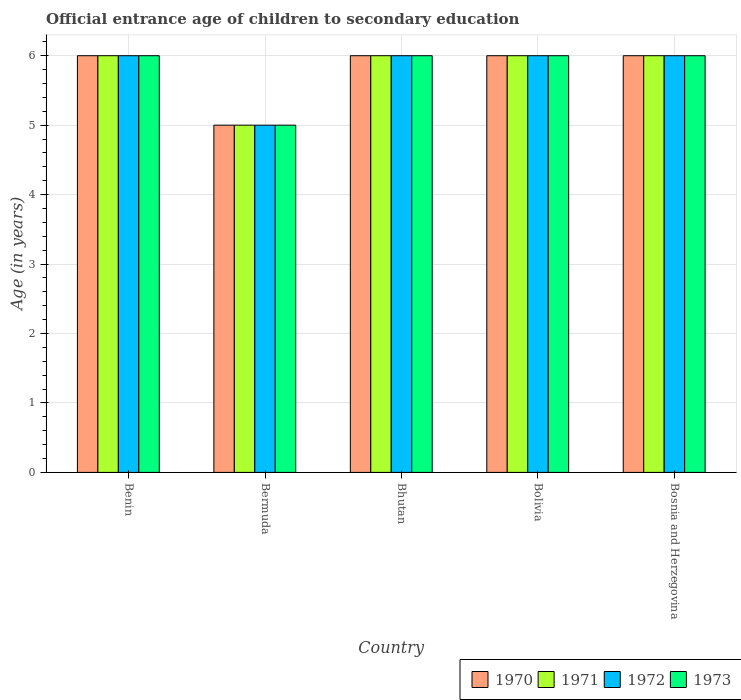How many different coloured bars are there?
Offer a terse response. 4. Are the number of bars on each tick of the X-axis equal?
Provide a short and direct response. Yes. How many bars are there on the 3rd tick from the left?
Offer a very short reply. 4. How many bars are there on the 2nd tick from the right?
Offer a terse response. 4. What is the label of the 2nd group of bars from the left?
Keep it short and to the point. Bermuda. What is the secondary school starting age of children in 1973 in Bermuda?
Ensure brevity in your answer.  5. In which country was the secondary school starting age of children in 1971 maximum?
Provide a short and direct response. Benin. In which country was the secondary school starting age of children in 1972 minimum?
Give a very brief answer. Bermuda. What is the total secondary school starting age of children in 1970 in the graph?
Your answer should be compact. 29. What is the difference between the secondary school starting age of children in 1972 in Bhutan and that in Bosnia and Herzegovina?
Provide a short and direct response. 0. What is the difference between the secondary school starting age of children of/in 1973 and secondary school starting age of children of/in 1970 in Bermuda?
Make the answer very short. 0. In how many countries, is the secondary school starting age of children in 1971 greater than 0.8 years?
Your answer should be compact. 5. Is the difference between the secondary school starting age of children in 1973 in Bhutan and Bolivia greater than the difference between the secondary school starting age of children in 1970 in Bhutan and Bolivia?
Your answer should be very brief. No. In how many countries, is the secondary school starting age of children in 1970 greater than the average secondary school starting age of children in 1970 taken over all countries?
Make the answer very short. 4. Is it the case that in every country, the sum of the secondary school starting age of children in 1971 and secondary school starting age of children in 1973 is greater than the sum of secondary school starting age of children in 1972 and secondary school starting age of children in 1970?
Your response must be concise. No. What does the 1st bar from the left in Benin represents?
Ensure brevity in your answer.  1970. What does the 4th bar from the right in Bhutan represents?
Keep it short and to the point. 1970. Is it the case that in every country, the sum of the secondary school starting age of children in 1973 and secondary school starting age of children in 1970 is greater than the secondary school starting age of children in 1971?
Offer a terse response. Yes. Are all the bars in the graph horizontal?
Offer a very short reply. No. How many countries are there in the graph?
Your answer should be very brief. 5. What is the difference between two consecutive major ticks on the Y-axis?
Offer a terse response. 1. Are the values on the major ticks of Y-axis written in scientific E-notation?
Provide a succinct answer. No. Where does the legend appear in the graph?
Offer a very short reply. Bottom right. How are the legend labels stacked?
Provide a succinct answer. Horizontal. What is the title of the graph?
Provide a short and direct response. Official entrance age of children to secondary education. What is the label or title of the X-axis?
Your response must be concise. Country. What is the label or title of the Y-axis?
Ensure brevity in your answer.  Age (in years). What is the Age (in years) in 1971 in Benin?
Your answer should be very brief. 6. What is the Age (in years) of 1973 in Benin?
Your response must be concise. 6. What is the Age (in years) in 1971 in Bermuda?
Keep it short and to the point. 5. What is the Age (in years) of 1972 in Bermuda?
Offer a very short reply. 5. What is the Age (in years) in 1971 in Bhutan?
Ensure brevity in your answer.  6. What is the Age (in years) in 1970 in Bolivia?
Your answer should be compact. 6. What is the Age (in years) of 1973 in Bolivia?
Provide a succinct answer. 6. What is the Age (in years) of 1971 in Bosnia and Herzegovina?
Give a very brief answer. 6. What is the Age (in years) in 1972 in Bosnia and Herzegovina?
Give a very brief answer. 6. Across all countries, what is the maximum Age (in years) of 1972?
Your response must be concise. 6. Across all countries, what is the minimum Age (in years) in 1972?
Provide a short and direct response. 5. What is the total Age (in years) in 1970 in the graph?
Give a very brief answer. 29. What is the total Age (in years) of 1972 in the graph?
Your response must be concise. 29. What is the total Age (in years) of 1973 in the graph?
Provide a succinct answer. 29. What is the difference between the Age (in years) in 1972 in Benin and that in Bermuda?
Keep it short and to the point. 1. What is the difference between the Age (in years) of 1972 in Benin and that in Bhutan?
Your response must be concise. 0. What is the difference between the Age (in years) in 1973 in Benin and that in Bhutan?
Keep it short and to the point. 0. What is the difference between the Age (in years) of 1970 in Benin and that in Bosnia and Herzegovina?
Offer a terse response. 0. What is the difference between the Age (in years) in 1971 in Benin and that in Bosnia and Herzegovina?
Give a very brief answer. 0. What is the difference between the Age (in years) in 1970 in Bermuda and that in Bhutan?
Offer a terse response. -1. What is the difference between the Age (in years) of 1971 in Bermuda and that in Bhutan?
Ensure brevity in your answer.  -1. What is the difference between the Age (in years) of 1972 in Bermuda and that in Bhutan?
Offer a very short reply. -1. What is the difference between the Age (in years) in 1973 in Bermuda and that in Bhutan?
Offer a terse response. -1. What is the difference between the Age (in years) in 1970 in Bermuda and that in Bolivia?
Ensure brevity in your answer.  -1. What is the difference between the Age (in years) of 1973 in Bermuda and that in Bolivia?
Your response must be concise. -1. What is the difference between the Age (in years) in 1971 in Bermuda and that in Bosnia and Herzegovina?
Provide a short and direct response. -1. What is the difference between the Age (in years) in 1973 in Bermuda and that in Bosnia and Herzegovina?
Keep it short and to the point. -1. What is the difference between the Age (in years) of 1970 in Bhutan and that in Bolivia?
Your answer should be compact. 0. What is the difference between the Age (in years) of 1971 in Bhutan and that in Bolivia?
Keep it short and to the point. 0. What is the difference between the Age (in years) in 1973 in Bhutan and that in Bolivia?
Provide a short and direct response. 0. What is the difference between the Age (in years) in 1971 in Bhutan and that in Bosnia and Herzegovina?
Provide a succinct answer. 0. What is the difference between the Age (in years) in 1972 in Bhutan and that in Bosnia and Herzegovina?
Offer a terse response. 0. What is the difference between the Age (in years) in 1973 in Bhutan and that in Bosnia and Herzegovina?
Make the answer very short. 0. What is the difference between the Age (in years) in 1971 in Bolivia and that in Bosnia and Herzegovina?
Give a very brief answer. 0. What is the difference between the Age (in years) in 1970 in Benin and the Age (in years) in 1971 in Bermuda?
Offer a very short reply. 1. What is the difference between the Age (in years) of 1972 in Benin and the Age (in years) of 1973 in Bhutan?
Your response must be concise. 0. What is the difference between the Age (in years) of 1970 in Benin and the Age (in years) of 1973 in Bolivia?
Your answer should be compact. 0. What is the difference between the Age (in years) in 1971 in Benin and the Age (in years) in 1972 in Bolivia?
Offer a very short reply. 0. What is the difference between the Age (in years) of 1972 in Benin and the Age (in years) of 1973 in Bolivia?
Your response must be concise. 0. What is the difference between the Age (in years) of 1971 in Benin and the Age (in years) of 1973 in Bosnia and Herzegovina?
Ensure brevity in your answer.  0. What is the difference between the Age (in years) in 1970 in Bermuda and the Age (in years) in 1972 in Bhutan?
Your answer should be compact. -1. What is the difference between the Age (in years) in 1970 in Bermuda and the Age (in years) in 1973 in Bhutan?
Ensure brevity in your answer.  -1. What is the difference between the Age (in years) of 1972 in Bermuda and the Age (in years) of 1973 in Bhutan?
Provide a short and direct response. -1. What is the difference between the Age (in years) in 1970 in Bermuda and the Age (in years) in 1973 in Bolivia?
Your answer should be very brief. -1. What is the difference between the Age (in years) of 1971 in Bermuda and the Age (in years) of 1973 in Bolivia?
Give a very brief answer. -1. What is the difference between the Age (in years) in 1970 in Bermuda and the Age (in years) in 1971 in Bosnia and Herzegovina?
Provide a succinct answer. -1. What is the difference between the Age (in years) in 1971 in Bermuda and the Age (in years) in 1972 in Bosnia and Herzegovina?
Make the answer very short. -1. What is the difference between the Age (in years) in 1971 in Bermuda and the Age (in years) in 1973 in Bosnia and Herzegovina?
Make the answer very short. -1. What is the difference between the Age (in years) of 1972 in Bermuda and the Age (in years) of 1973 in Bosnia and Herzegovina?
Keep it short and to the point. -1. What is the difference between the Age (in years) in 1970 in Bhutan and the Age (in years) in 1971 in Bolivia?
Keep it short and to the point. 0. What is the difference between the Age (in years) of 1970 in Bhutan and the Age (in years) of 1972 in Bolivia?
Provide a short and direct response. 0. What is the difference between the Age (in years) in 1971 in Bhutan and the Age (in years) in 1973 in Bolivia?
Your answer should be very brief. 0. What is the difference between the Age (in years) of 1970 in Bhutan and the Age (in years) of 1972 in Bosnia and Herzegovina?
Your answer should be very brief. 0. What is the difference between the Age (in years) of 1970 in Bolivia and the Age (in years) of 1972 in Bosnia and Herzegovina?
Your answer should be compact. 0. What is the difference between the Age (in years) in 1971 in Bolivia and the Age (in years) in 1972 in Bosnia and Herzegovina?
Give a very brief answer. 0. What is the difference between the Age (in years) of 1971 in Bolivia and the Age (in years) of 1973 in Bosnia and Herzegovina?
Keep it short and to the point. 0. What is the average Age (in years) of 1973 per country?
Ensure brevity in your answer.  5.8. What is the difference between the Age (in years) of 1970 and Age (in years) of 1971 in Benin?
Your response must be concise. 0. What is the difference between the Age (in years) of 1970 and Age (in years) of 1972 in Benin?
Your answer should be compact. 0. What is the difference between the Age (in years) of 1970 and Age (in years) of 1973 in Benin?
Provide a short and direct response. 0. What is the difference between the Age (in years) of 1971 and Age (in years) of 1973 in Benin?
Provide a short and direct response. 0. What is the difference between the Age (in years) in 1972 and Age (in years) in 1973 in Benin?
Give a very brief answer. 0. What is the difference between the Age (in years) of 1970 and Age (in years) of 1971 in Bermuda?
Give a very brief answer. 0. What is the difference between the Age (in years) in 1971 and Age (in years) in 1972 in Bermuda?
Make the answer very short. 0. What is the difference between the Age (in years) in 1971 and Age (in years) in 1973 in Bermuda?
Provide a short and direct response. 0. What is the difference between the Age (in years) in 1972 and Age (in years) in 1973 in Bermuda?
Offer a terse response. 0. What is the difference between the Age (in years) of 1970 and Age (in years) of 1973 in Bhutan?
Provide a succinct answer. 0. What is the difference between the Age (in years) in 1971 and Age (in years) in 1973 in Bhutan?
Offer a terse response. 0. What is the difference between the Age (in years) in 1970 and Age (in years) in 1972 in Bolivia?
Offer a very short reply. 0. What is the difference between the Age (in years) of 1970 and Age (in years) of 1973 in Bolivia?
Keep it short and to the point. 0. What is the difference between the Age (in years) in 1971 and Age (in years) in 1973 in Bolivia?
Ensure brevity in your answer.  0. What is the difference between the Age (in years) of 1972 and Age (in years) of 1973 in Bolivia?
Offer a very short reply. 0. What is the difference between the Age (in years) in 1970 and Age (in years) in 1971 in Bosnia and Herzegovina?
Offer a very short reply. 0. What is the difference between the Age (in years) of 1970 and Age (in years) of 1972 in Bosnia and Herzegovina?
Offer a terse response. 0. What is the difference between the Age (in years) of 1970 and Age (in years) of 1973 in Bosnia and Herzegovina?
Provide a succinct answer. 0. What is the difference between the Age (in years) in 1971 and Age (in years) in 1973 in Bosnia and Herzegovina?
Your response must be concise. 0. What is the difference between the Age (in years) in 1972 and Age (in years) in 1973 in Bosnia and Herzegovina?
Offer a very short reply. 0. What is the ratio of the Age (in years) of 1970 in Benin to that in Bermuda?
Provide a succinct answer. 1.2. What is the ratio of the Age (in years) of 1972 in Benin to that in Bermuda?
Provide a short and direct response. 1.2. What is the ratio of the Age (in years) of 1970 in Benin to that in Bhutan?
Ensure brevity in your answer.  1. What is the ratio of the Age (in years) of 1971 in Benin to that in Bhutan?
Offer a very short reply. 1. What is the ratio of the Age (in years) of 1972 in Benin to that in Bhutan?
Keep it short and to the point. 1. What is the ratio of the Age (in years) of 1973 in Benin to that in Bhutan?
Provide a succinct answer. 1. What is the ratio of the Age (in years) in 1973 in Benin to that in Bolivia?
Your answer should be very brief. 1. What is the ratio of the Age (in years) of 1970 in Benin to that in Bosnia and Herzegovina?
Make the answer very short. 1. What is the ratio of the Age (in years) of 1971 in Benin to that in Bosnia and Herzegovina?
Your answer should be compact. 1. What is the ratio of the Age (in years) in 1973 in Benin to that in Bosnia and Herzegovina?
Provide a succinct answer. 1. What is the ratio of the Age (in years) of 1971 in Bermuda to that in Bhutan?
Offer a terse response. 0.83. What is the ratio of the Age (in years) of 1973 in Bermuda to that in Bhutan?
Ensure brevity in your answer.  0.83. What is the ratio of the Age (in years) in 1972 in Bermuda to that in Bolivia?
Offer a terse response. 0.83. What is the ratio of the Age (in years) in 1973 in Bermuda to that in Bolivia?
Provide a succinct answer. 0.83. What is the ratio of the Age (in years) in 1970 in Bermuda to that in Bosnia and Herzegovina?
Your answer should be compact. 0.83. What is the ratio of the Age (in years) of 1971 in Bermuda to that in Bosnia and Herzegovina?
Your answer should be very brief. 0.83. What is the ratio of the Age (in years) in 1970 in Bhutan to that in Bolivia?
Your answer should be very brief. 1. What is the ratio of the Age (in years) of 1971 in Bhutan to that in Bolivia?
Keep it short and to the point. 1. What is the ratio of the Age (in years) of 1973 in Bhutan to that in Bolivia?
Give a very brief answer. 1. What is the ratio of the Age (in years) of 1970 in Bhutan to that in Bosnia and Herzegovina?
Offer a terse response. 1. What is the ratio of the Age (in years) of 1971 in Bolivia to that in Bosnia and Herzegovina?
Ensure brevity in your answer.  1. What is the ratio of the Age (in years) in 1972 in Bolivia to that in Bosnia and Herzegovina?
Keep it short and to the point. 1. What is the difference between the highest and the second highest Age (in years) in 1972?
Make the answer very short. 0. What is the difference between the highest and the second highest Age (in years) of 1973?
Your answer should be compact. 0. What is the difference between the highest and the lowest Age (in years) in 1970?
Make the answer very short. 1. What is the difference between the highest and the lowest Age (in years) in 1971?
Offer a terse response. 1. What is the difference between the highest and the lowest Age (in years) in 1972?
Your response must be concise. 1. 